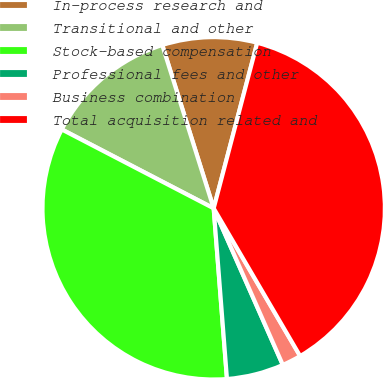<chart> <loc_0><loc_0><loc_500><loc_500><pie_chart><fcel>In-process research and<fcel>Transitional and other<fcel>Stock-based compensation<fcel>Professional fees and other<fcel>Business combination<fcel>Total acquisition related and<nl><fcel>8.95%<fcel>12.52%<fcel>33.86%<fcel>5.38%<fcel>1.81%<fcel>37.48%<nl></chart> 